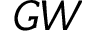<formula> <loc_0><loc_0><loc_500><loc_500>G W</formula> 